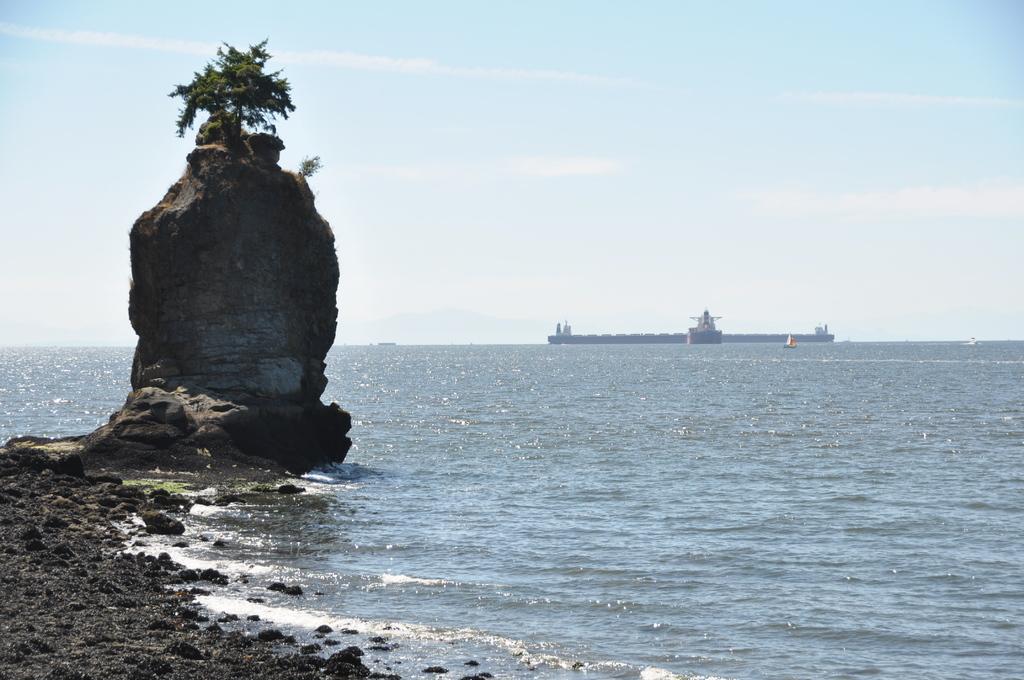Please provide a concise description of this image. In this image we can see boats and ship on the water. Also there are rocks. On the top of the rock there is a tree. In the background there is sky with clouds. 